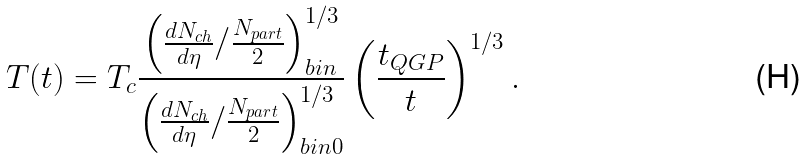Convert formula to latex. <formula><loc_0><loc_0><loc_500><loc_500>T ( t ) = T _ { c } \frac { \left ( \frac { d N _ { c h } } { d \eta } / \frac { N _ { p a r t } } { 2 } \right ) _ { b i n } ^ { 1 / 3 } } { \left ( \frac { d N _ { c h } } { d \eta } / \frac { N _ { p a r t } } { 2 } \right ) _ { b i n 0 } ^ { 1 / 3 } } \left ( \frac { t _ { Q G P } } { t } \right ) ^ { 1 / 3 } .</formula> 